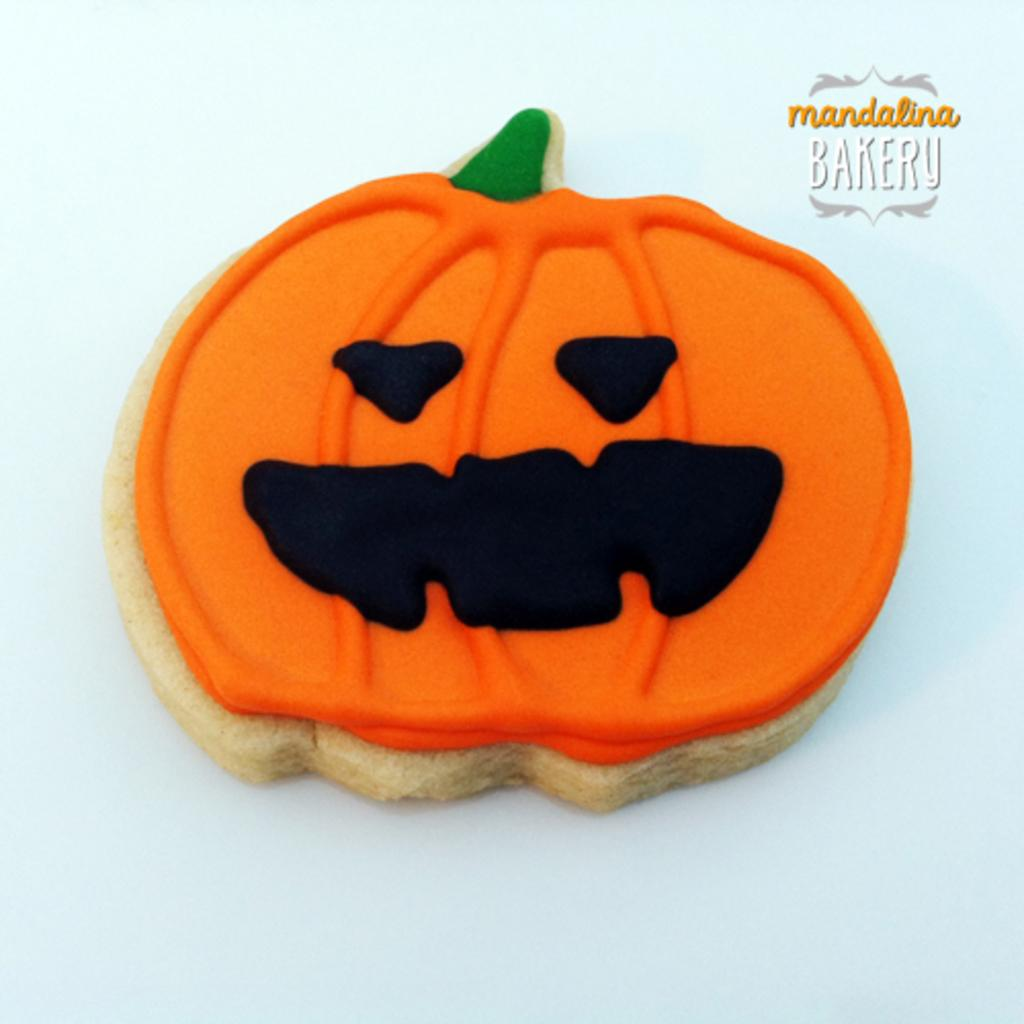What is the main subject of the image? There is a cookie in the image. What can be seen at the top right of the image? There is text at the top right of the image. What is visible in the background of the image? The background of the image features a plane. Is there a volcano erupting in the background of the image? No, there is no volcano present in the image. What type of caption is provided for the cookie in the image? There is no caption provided for the cookie in the image, as the text at the top right is not related to the cookie. 